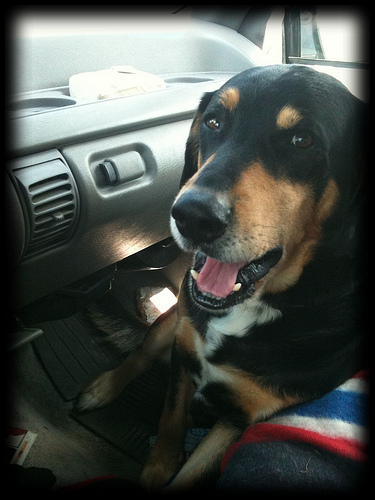<image>
Is there a vent to the left of the dog nose? Yes. From this viewpoint, the vent is positioned to the left side relative to the dog nose. Is there a dashboard above the dog? No. The dashboard is not positioned above the dog. The vertical arrangement shows a different relationship. 